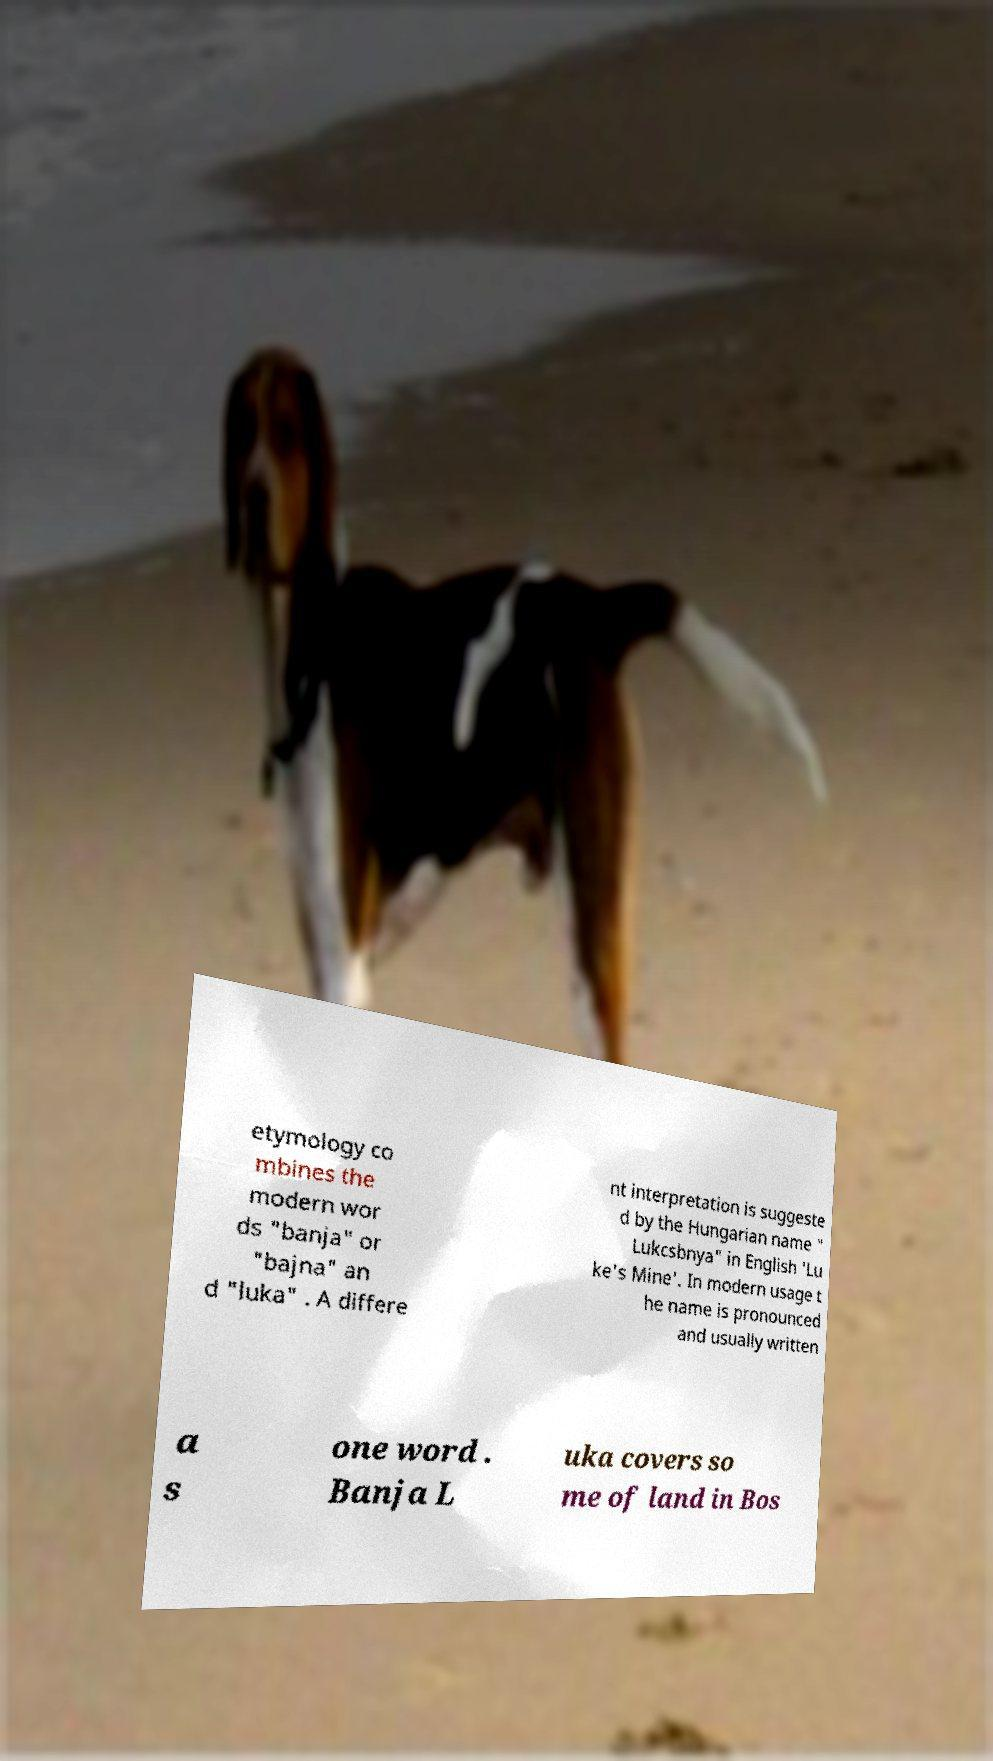Please read and relay the text visible in this image. What does it say? etymology co mbines the modern wor ds "banja" or "bajna" an d "luka" . A differe nt interpretation is suggeste d by the Hungarian name " Lukcsbnya" in English 'Lu ke's Mine'. In modern usage t he name is pronounced and usually written a s one word . Banja L uka covers so me of land in Bos 